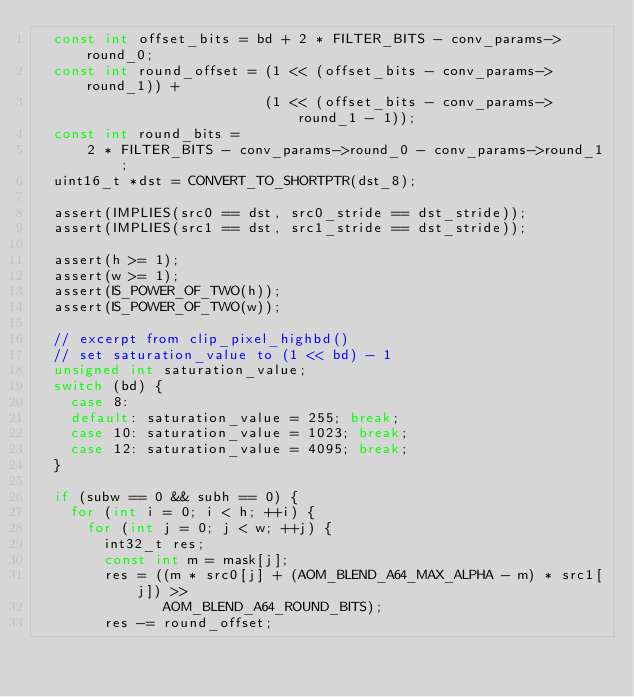Convert code to text. <code><loc_0><loc_0><loc_500><loc_500><_C_>  const int offset_bits = bd + 2 * FILTER_BITS - conv_params->round_0;
  const int round_offset = (1 << (offset_bits - conv_params->round_1)) +
                           (1 << (offset_bits - conv_params->round_1 - 1));
  const int round_bits =
      2 * FILTER_BITS - conv_params->round_0 - conv_params->round_1;
  uint16_t *dst = CONVERT_TO_SHORTPTR(dst_8);

  assert(IMPLIES(src0 == dst, src0_stride == dst_stride));
  assert(IMPLIES(src1 == dst, src1_stride == dst_stride));

  assert(h >= 1);
  assert(w >= 1);
  assert(IS_POWER_OF_TWO(h));
  assert(IS_POWER_OF_TWO(w));

  // excerpt from clip_pixel_highbd()
  // set saturation_value to (1 << bd) - 1
  unsigned int saturation_value;
  switch (bd) {
    case 8:
    default: saturation_value = 255; break;
    case 10: saturation_value = 1023; break;
    case 12: saturation_value = 4095; break;
  }

  if (subw == 0 && subh == 0) {
    for (int i = 0; i < h; ++i) {
      for (int j = 0; j < w; ++j) {
        int32_t res;
        const int m = mask[j];
        res = ((m * src0[j] + (AOM_BLEND_A64_MAX_ALPHA - m) * src1[j]) >>
               AOM_BLEND_A64_ROUND_BITS);
        res -= round_offset;</code> 